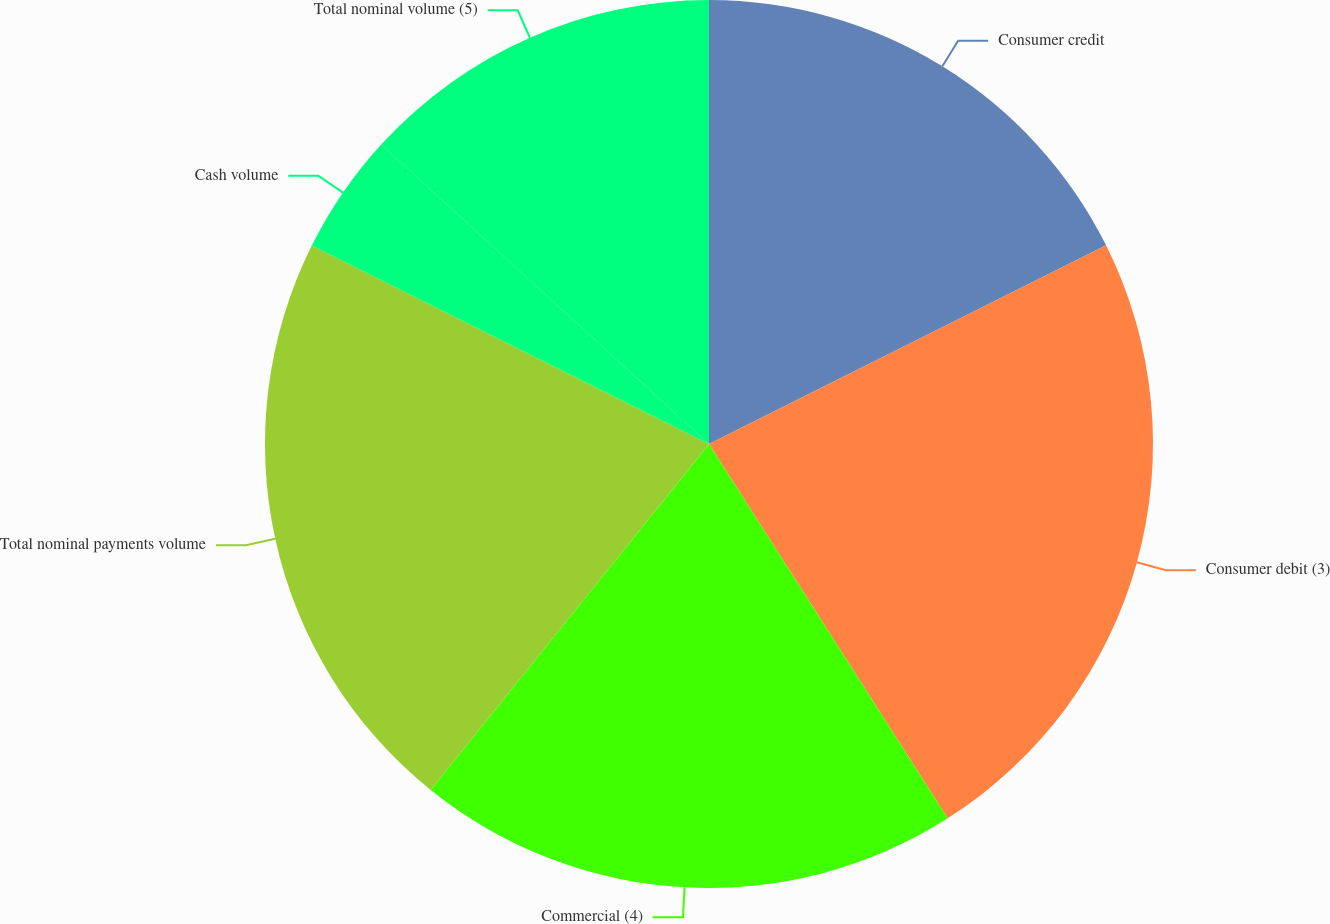Convert chart to OTSL. <chart><loc_0><loc_0><loc_500><loc_500><pie_chart><fcel>Consumer credit<fcel>Consumer debit (3)<fcel>Commercial (4)<fcel>Total nominal payments volume<fcel>Cash volume<fcel>Total nominal volume (5)<nl><fcel>17.62%<fcel>23.35%<fcel>19.82%<fcel>21.59%<fcel>4.41%<fcel>13.22%<nl></chart> 